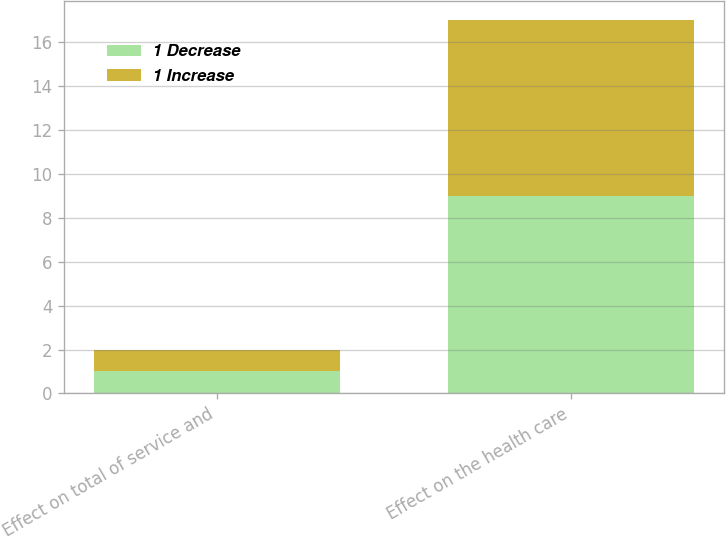Convert chart to OTSL. <chart><loc_0><loc_0><loc_500><loc_500><stacked_bar_chart><ecel><fcel>Effect on total of service and<fcel>Effect on the health care<nl><fcel>1 Decrease<fcel>1<fcel>9<nl><fcel>1 Increase<fcel>1<fcel>8<nl></chart> 